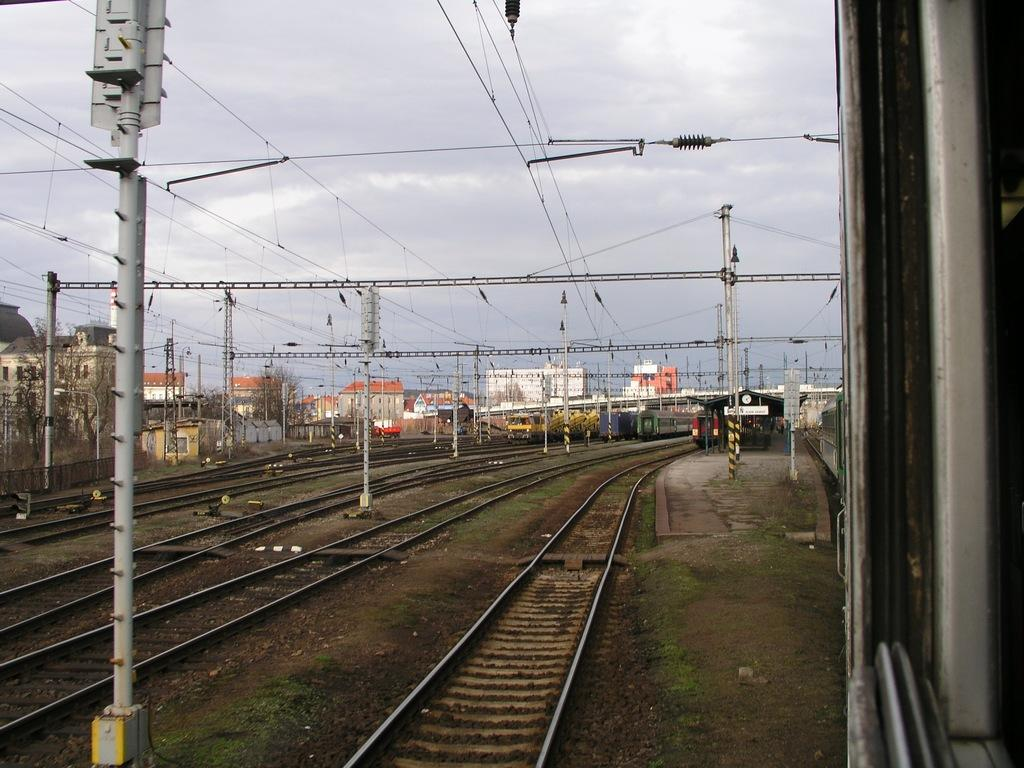What is the main subject of the image? The main subject of the image is trains on the railway track. What can be seen in the background of the image? There are buildings, trees, and the sky visible in the background of the image. Can you tell me how many squirrels are sitting on the train in the image? There are no squirrels present in the image; the main subject is the trains on the railway track. 